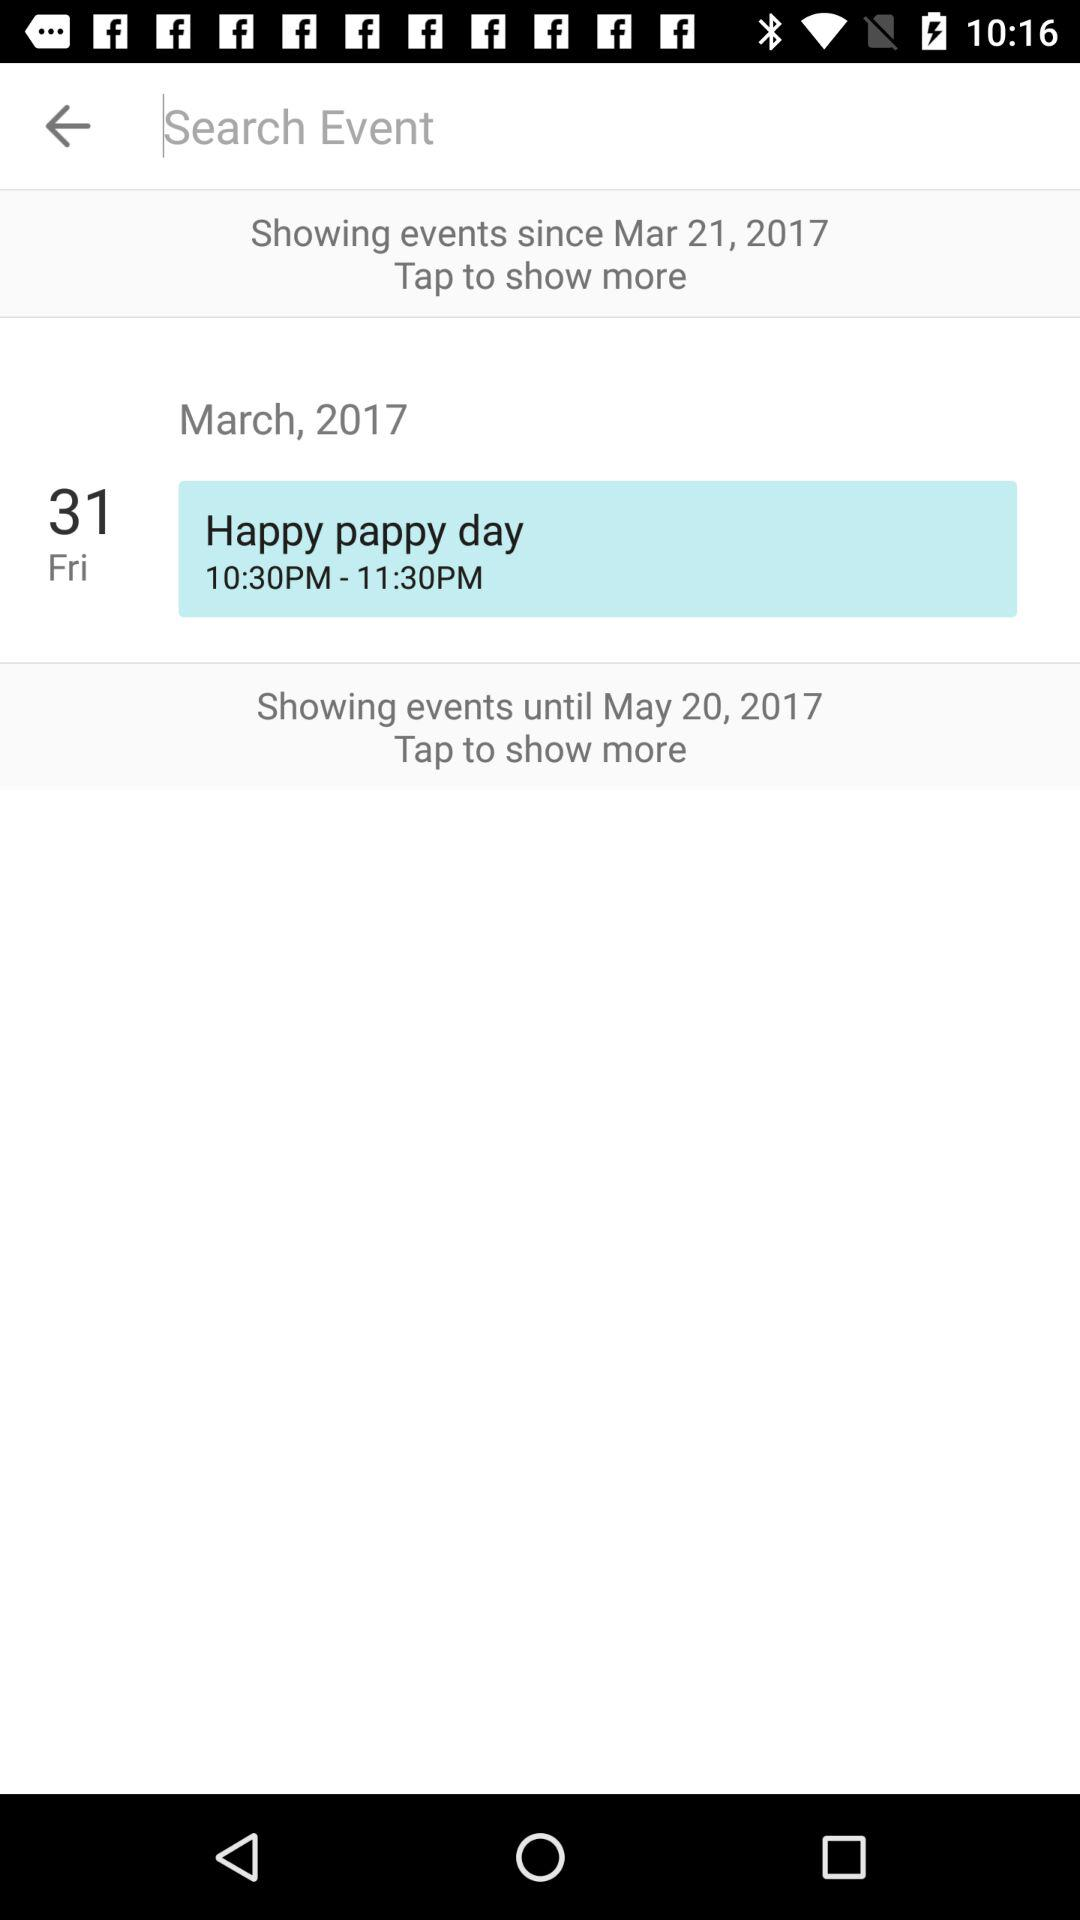What is the posted date of the event? The posted date of the event is Friday, March 31, 2017. 